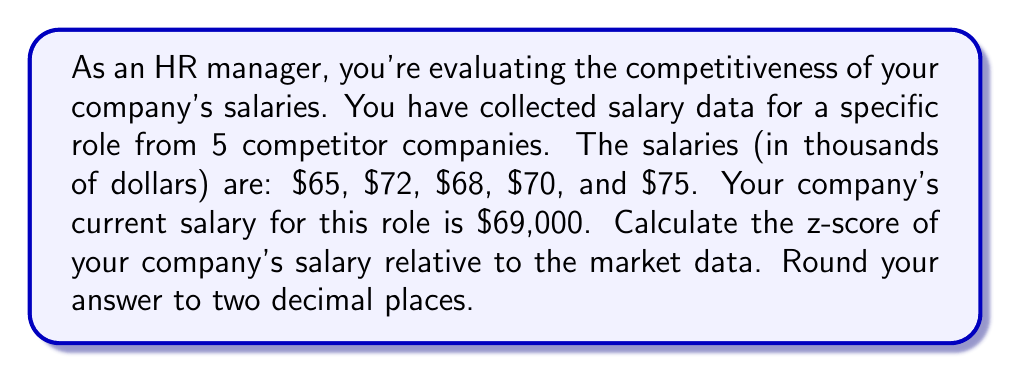Teach me how to tackle this problem. To calculate the z-score, we need to follow these steps:

1. Calculate the mean (average) of the competitor salaries:
   $$\mu = \frac{65 + 72 + 68 + 70 + 75}{5} = 70$$

2. Calculate the standard deviation of the competitor salaries:
   $$\sigma = \sqrt{\frac{\sum_{i=1}^{n} (x_i - \mu)^2}{n}}$$
   
   Where $x_i$ are the individual salaries and $n$ is the number of salaries.
   
   $$\sigma = \sqrt{\frac{(65-70)^2 + (72-70)^2 + (68-70)^2 + (70-70)^2 + (75-70)^2}{5}}$$
   $$\sigma = \sqrt{\frac{25 + 4 + 4 + 0 + 25}{5}} = \sqrt{\frac{58}{5}} \approx 3.4$$

3. Calculate the z-score using the formula:
   $$z = \frac{x - \mu}{\sigma}$$
   
   Where $x$ is your company's salary, $\mu$ is the mean of competitor salaries, and $\sigma$ is the standard deviation.
   
   $$z = \frac{69 - 70}{3.4} \approx -0.2941$$

4. Round the result to two decimal places:
   $-0.29$
Answer: $-0.29$ 